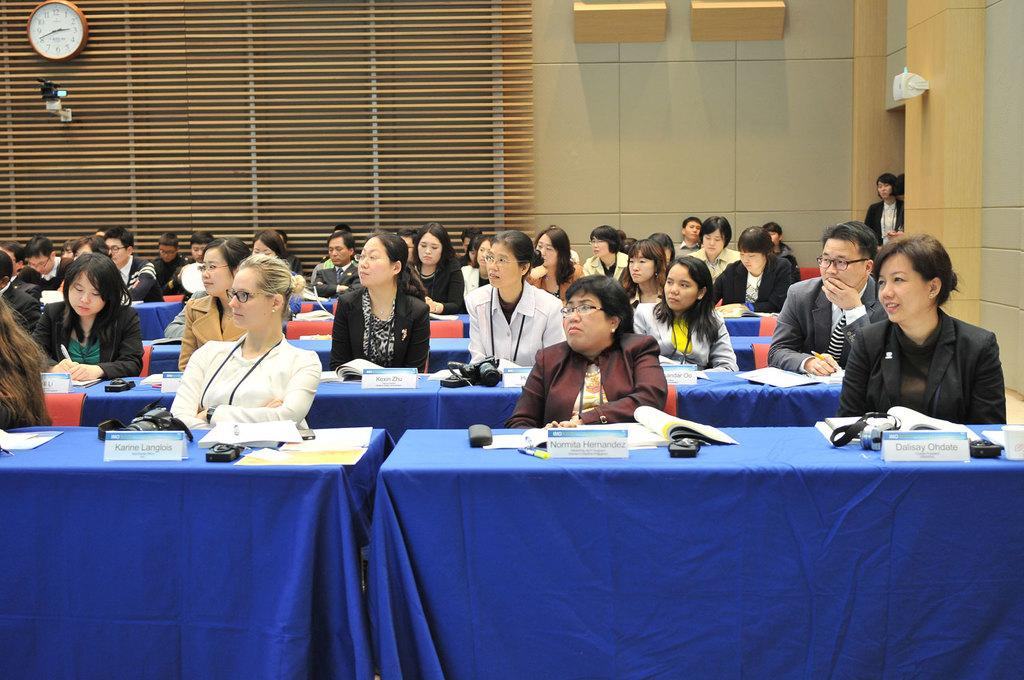What is present in the image that serves as a barrier or divider? There is a wall in the image. What are the people in the image doing? The people in the image are sitting on chairs. What furniture is present in the image? There are tables in the image. What items can be seen on the tables? There are papers, books, a mouse, and a camera on the tables. Can you tell me how many boys are joining the group in the image? There is no mention of a boy or joining a group in the image. What type of sticks are being used by the people in the image? There are no sticks present in the image. 